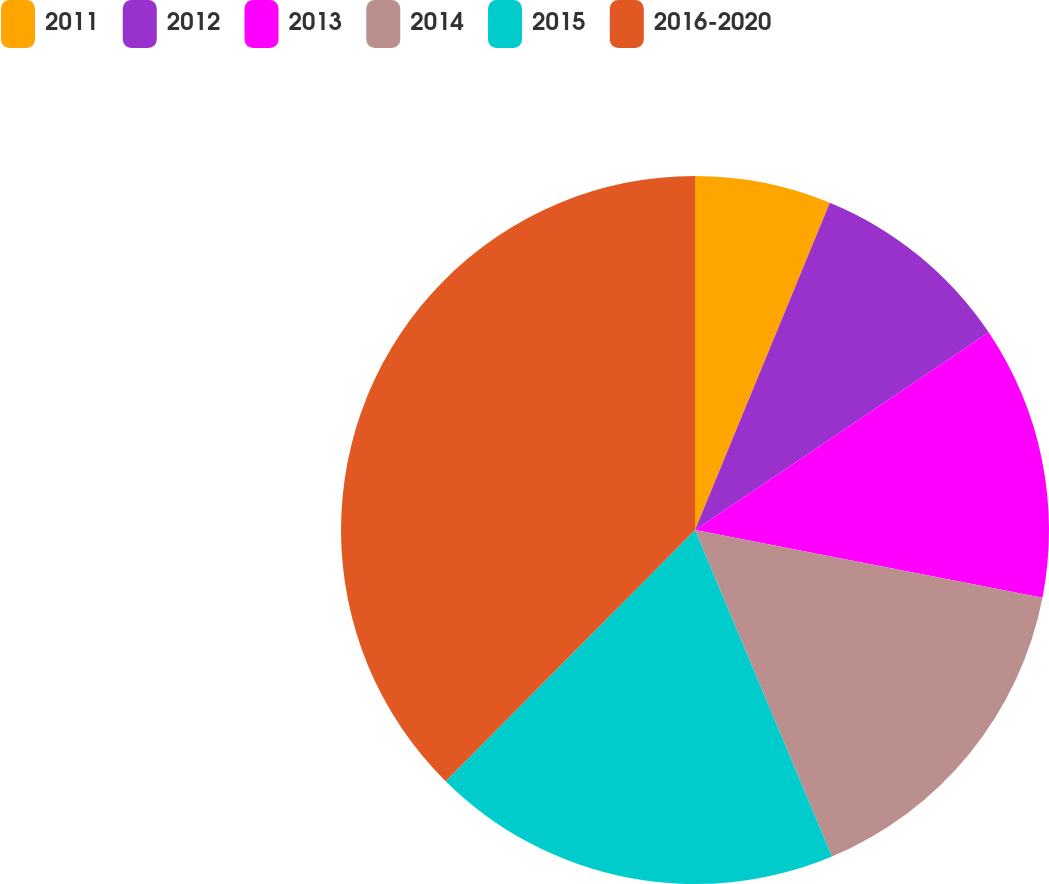Convert chart. <chart><loc_0><loc_0><loc_500><loc_500><pie_chart><fcel>2011<fcel>2012<fcel>2013<fcel>2014<fcel>2015<fcel>2016-2020<nl><fcel>6.22%<fcel>9.35%<fcel>12.49%<fcel>15.62%<fcel>18.76%<fcel>37.56%<nl></chart> 